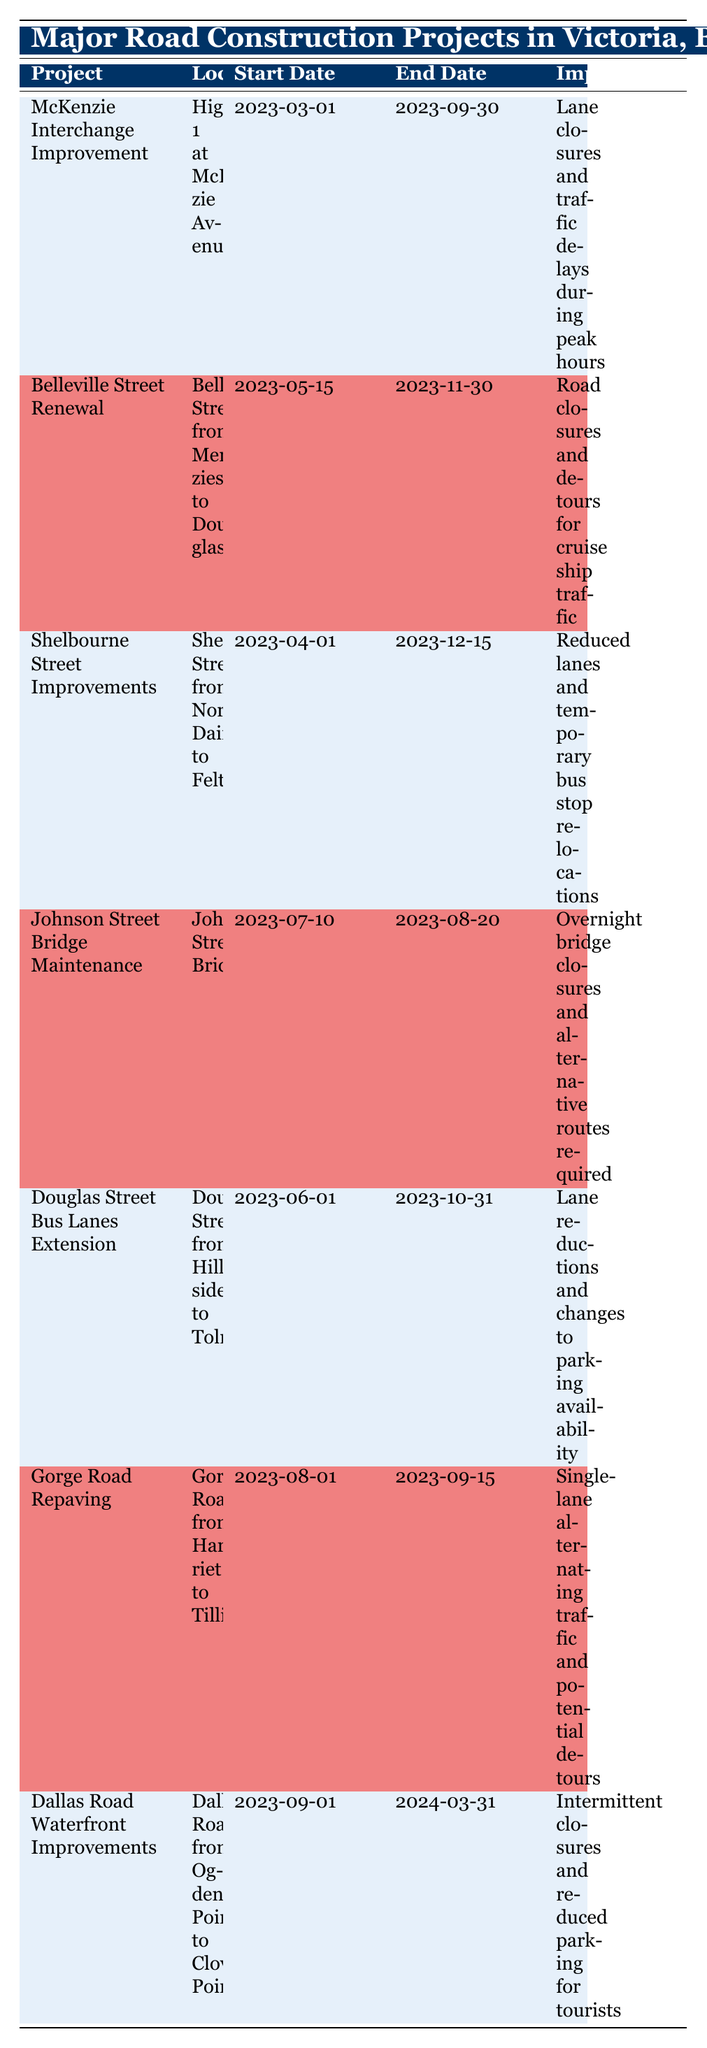What is the impact of the McKenzie Interchange Improvement project? The McKenzie Interchange Improvement project has the impact of lane closures and traffic delays during peak hours, as stated in the table under the 'Impact' column for that specific project.
Answer: Lane closures and traffic delays during peak hours When does the Belleville Street Renewal project start and end? According to the table, the start date for the Belleville Street Renewal project is May 15, 2023, and the end date is November 30, 2023, which can be retrieved directly from the respective columns.
Answer: May 15, 2023, to November 30, 2023 Is the Johnson Street Bridge Maintenance project longer than two months? The Johnson Street Bridge Maintenance project starts on July 10, 2023, and ends on August 20, 2023. The total duration can be calculated by looking at the start and end dates, giving a duration of 41 days, which is less than two months.
Answer: No How many construction projects start in the month of June? By scanning the table, there is one project that starts in June (Douglas Street Bus Lanes Extension on June 1, 2023). This involves counting the number of projects that have their start date in June.
Answer: One What is the total duration of the Gorge Road Repaving project? The Gorge Road Repaving project starts on August 1, 2023, and ends on September 15, 2023. The duration can be calculated as follows: from August 1 to September 15 is a total of 45 days.
Answer: 45 days Does the Dallas Road Waterfront Improvements project have any impact on tourist parking? Yes, the Dallas Road Waterfront Improvements project has an impact on reduced parking for tourists, as clearly mentioned in the 'Impact' column of the relevant row in the table.
Answer: Yes Which project has the longest duration and what is that duration? By examining the start and end dates for each project in the table, the Shelbourne Street Improvements project lasts from April 1, 2023, to December 15, 2023, which totals 228 days, making it the longest duration project.
Answer: 228 days What is the earliest start date among all the projects listed? The earliest start date can be identified by comparing all the start dates provided in the table. The earliest is March 1, 2023, for the McKenzie Interchange Improvement.
Answer: March 1, 2023 